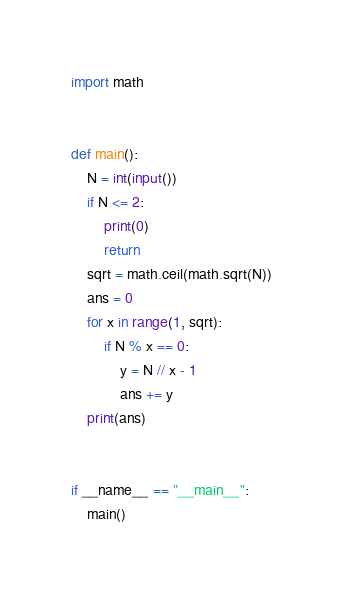<code> <loc_0><loc_0><loc_500><loc_500><_Python_>import math


def main():
    N = int(input())
    if N <= 2:
        print(0)
        return
    sqrt = math.ceil(math.sqrt(N))
    ans = 0
    for x in range(1, sqrt):
        if N % x == 0:
            y = N // x - 1
            ans += y
    print(ans)


if __name__ == "__main__":
    main()
</code> 